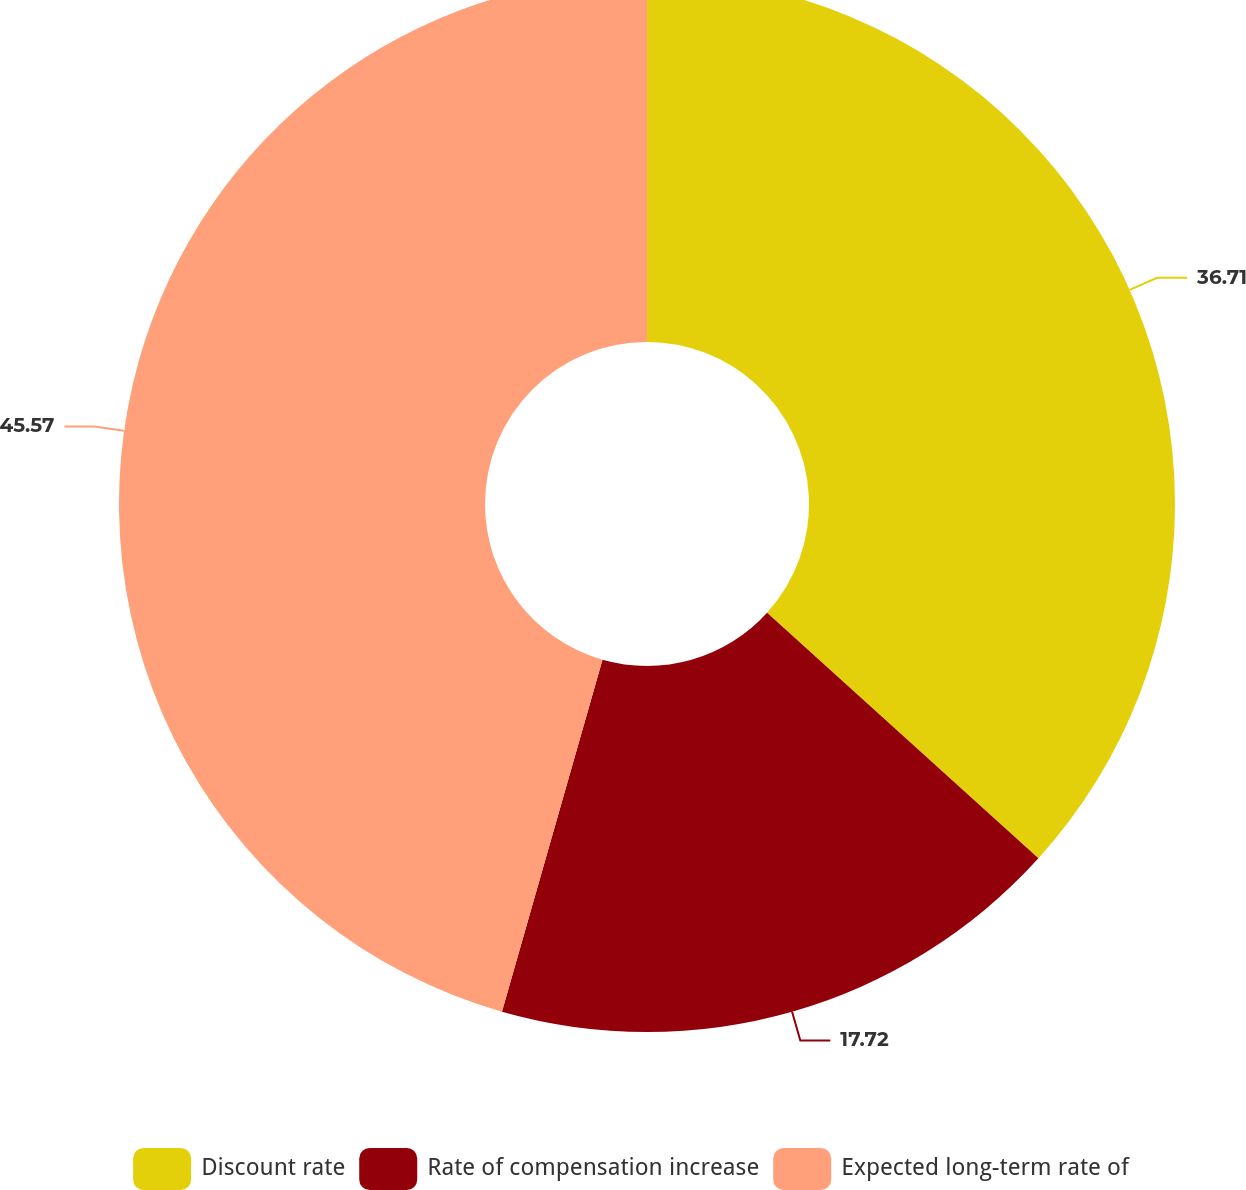<chart> <loc_0><loc_0><loc_500><loc_500><pie_chart><fcel>Discount rate<fcel>Rate of compensation increase<fcel>Expected long-term rate of<nl><fcel>36.71%<fcel>17.72%<fcel>45.57%<nl></chart> 